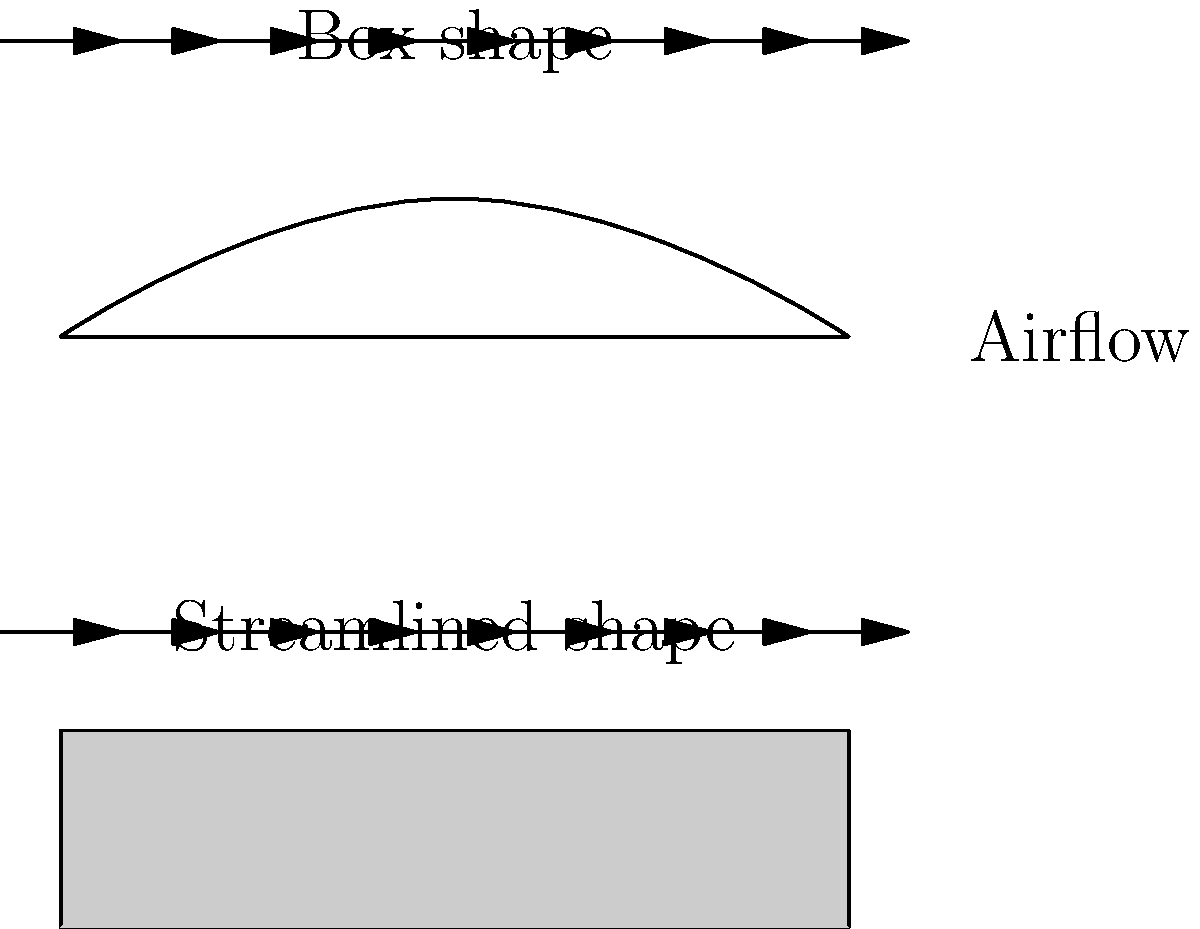In a racing game simulation, you need to model the aerodynamic downforce for two different car body shapes: a box shape and a streamlined shape. Given that the downforce coefficient ($C_d$) for the box shape is 0.8 and for the streamlined shape is 0.3, calculate the ratio of downforce generated by the streamlined shape to the box shape. Assume all other factors (frontal area, air density, and velocity) are identical for both shapes. Express your answer as a decimal rounded to two places. To solve this problem, let's follow these steps:

1) The formula for downforce ($F_d$) is:

   $$F_d = \frac{1}{2} \rho v^2 A C_d$$

   Where:
   $\rho$ is air density
   $v$ is velocity
   $A$ is frontal area
   $C_d$ is the downforce coefficient

2) We're told that all factors except $C_d$ are identical for both shapes. Let's call the common factors $K$:

   $$K = \frac{1}{2} \rho v^2 A$$

3) For the box shape:
   $$F_{d_{box}} = K \cdot 0.8$$

4) For the streamlined shape:
   $$F_{d_{streamlined}} = K \cdot 0.3$$

5) The ratio of downforce (streamlined to box) is:

   $$\frac{F_{d_{streamlined}}}{F_{d_{box}}} = \frac{K \cdot 0.3}{K \cdot 0.8}$$

6) The $K$ cancels out:

   $$\frac{F_{d_{streamlined}}}{F_{d_{box}}} = \frac{0.3}{0.8} = 0.375$$

7) Rounding to two decimal places:

   $$\frac{F_{d_{streamlined}}}{F_{d_{box}}} \approx 0.38$$
Answer: 0.38 